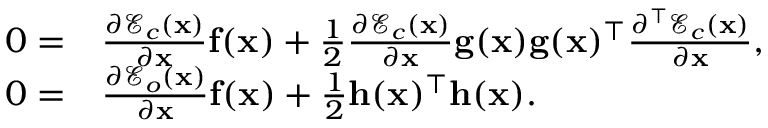<formula> <loc_0><loc_0><loc_500><loc_500>\begin{array} { r l } { 0 = } & { \frac { \partial \mathcal { E } _ { c } ( x ) } { \partial x } f ( x ) + \frac { 1 } { 2 } \frac { \partial \mathcal { E } _ { c } ( x ) } { \partial x } g ( x ) g ( x ) ^ { \top } \frac { \partial ^ { \top } \mathcal { E } _ { c } ( x ) } { \partial x } , } \\ { 0 = } & { \frac { \partial \mathcal { E } _ { o } ( x ) } { \partial x } f ( x ) + \frac { 1 } { 2 } h ( x ) ^ { \top } h ( x ) . } \end{array}</formula> 